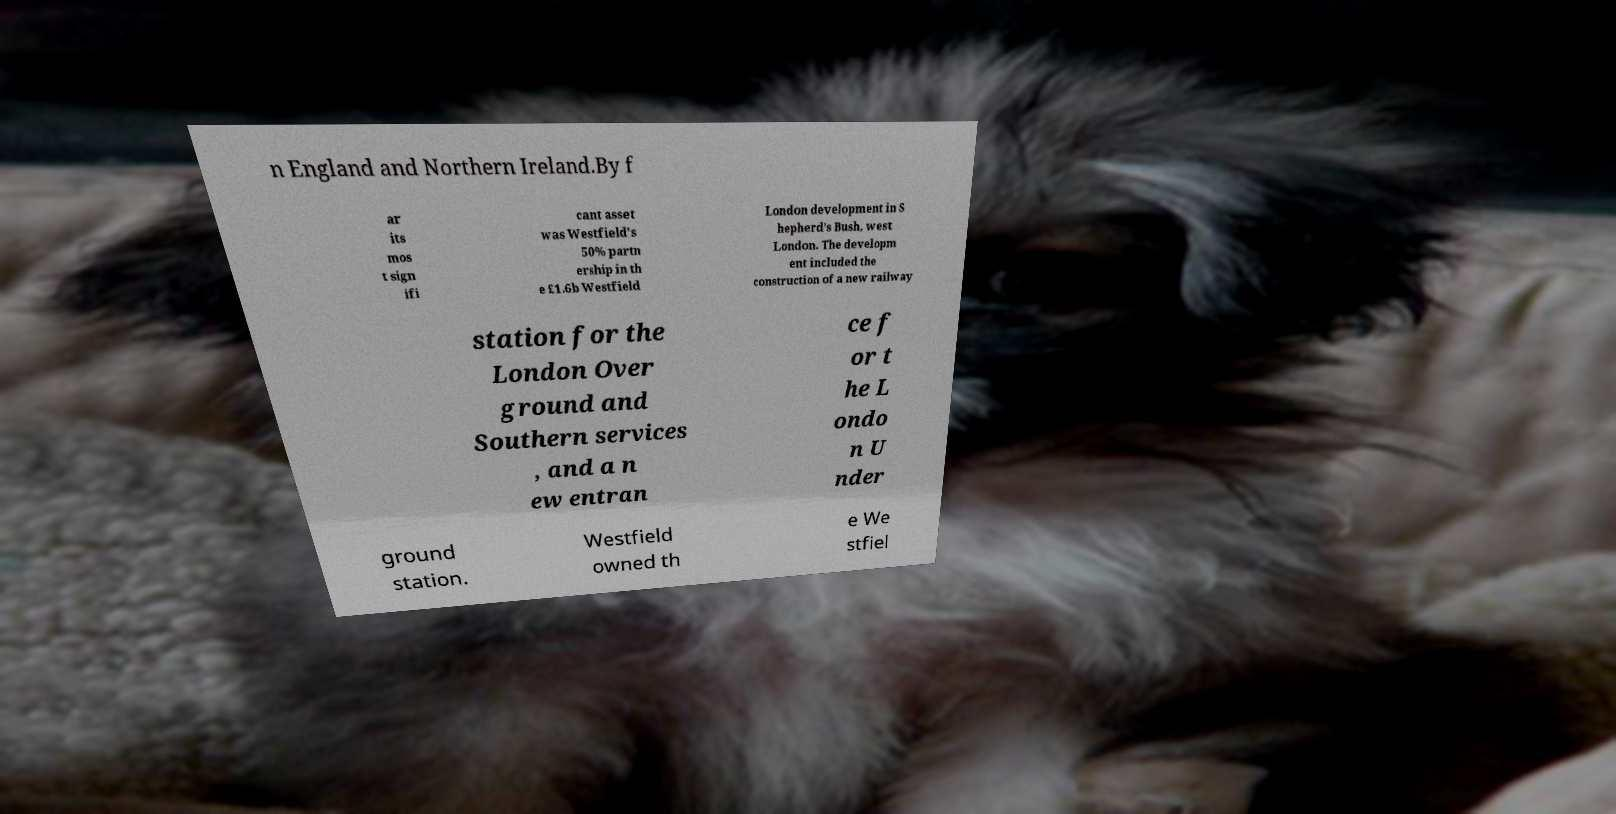Could you extract and type out the text from this image? n England and Northern Ireland.By f ar its mos t sign ifi cant asset was Westfield's 50% partn ership in th e £1.6b Westfield London development in S hepherd's Bush, west London. The developm ent included the construction of a new railway station for the London Over ground and Southern services , and a n ew entran ce f or t he L ondo n U nder ground station. Westfield owned th e We stfiel 